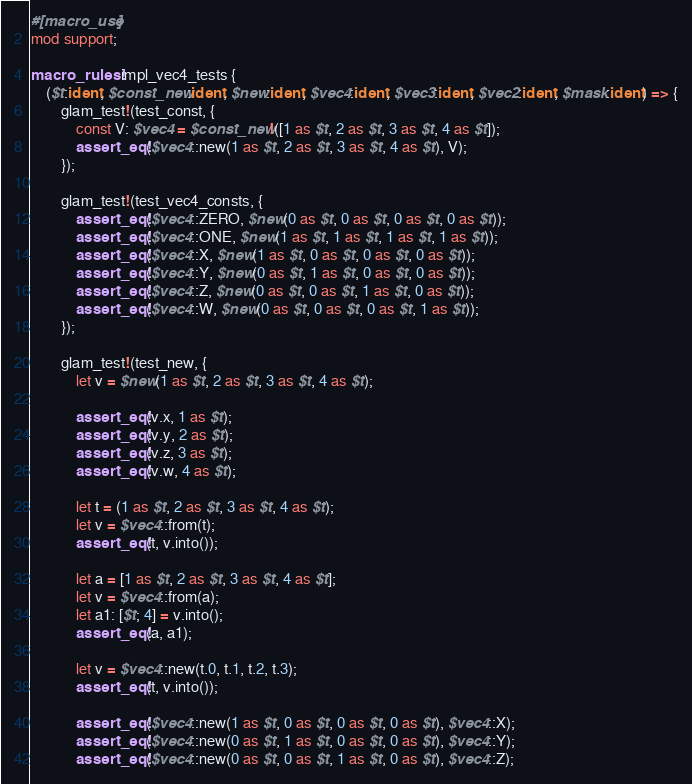Convert code to text. <code><loc_0><loc_0><loc_500><loc_500><_Rust_>#[macro_use]
mod support;

macro_rules! impl_vec4_tests {
    ($t:ident, $const_new:ident, $new:ident, $vec4:ident, $vec3:ident, $vec2:ident, $mask:ident) => {
        glam_test!(test_const, {
            const V: $vec4 = $const_new!([1 as $t, 2 as $t, 3 as $t, 4 as $t]);
            assert_eq!($vec4::new(1 as $t, 2 as $t, 3 as $t, 4 as $t), V);
        });

        glam_test!(test_vec4_consts, {
            assert_eq!($vec4::ZERO, $new(0 as $t, 0 as $t, 0 as $t, 0 as $t));
            assert_eq!($vec4::ONE, $new(1 as $t, 1 as $t, 1 as $t, 1 as $t));
            assert_eq!($vec4::X, $new(1 as $t, 0 as $t, 0 as $t, 0 as $t));
            assert_eq!($vec4::Y, $new(0 as $t, 1 as $t, 0 as $t, 0 as $t));
            assert_eq!($vec4::Z, $new(0 as $t, 0 as $t, 1 as $t, 0 as $t));
            assert_eq!($vec4::W, $new(0 as $t, 0 as $t, 0 as $t, 1 as $t));
        });

        glam_test!(test_new, {
            let v = $new(1 as $t, 2 as $t, 3 as $t, 4 as $t);

            assert_eq!(v.x, 1 as $t);
            assert_eq!(v.y, 2 as $t);
            assert_eq!(v.z, 3 as $t);
            assert_eq!(v.w, 4 as $t);

            let t = (1 as $t, 2 as $t, 3 as $t, 4 as $t);
            let v = $vec4::from(t);
            assert_eq!(t, v.into());

            let a = [1 as $t, 2 as $t, 3 as $t, 4 as $t];
            let v = $vec4::from(a);
            let a1: [$t; 4] = v.into();
            assert_eq!(a, a1);

            let v = $vec4::new(t.0, t.1, t.2, t.3);
            assert_eq!(t, v.into());

            assert_eq!($vec4::new(1 as $t, 0 as $t, 0 as $t, 0 as $t), $vec4::X);
            assert_eq!($vec4::new(0 as $t, 1 as $t, 0 as $t, 0 as $t), $vec4::Y);
            assert_eq!($vec4::new(0 as $t, 0 as $t, 1 as $t, 0 as $t), $vec4::Z);</code> 